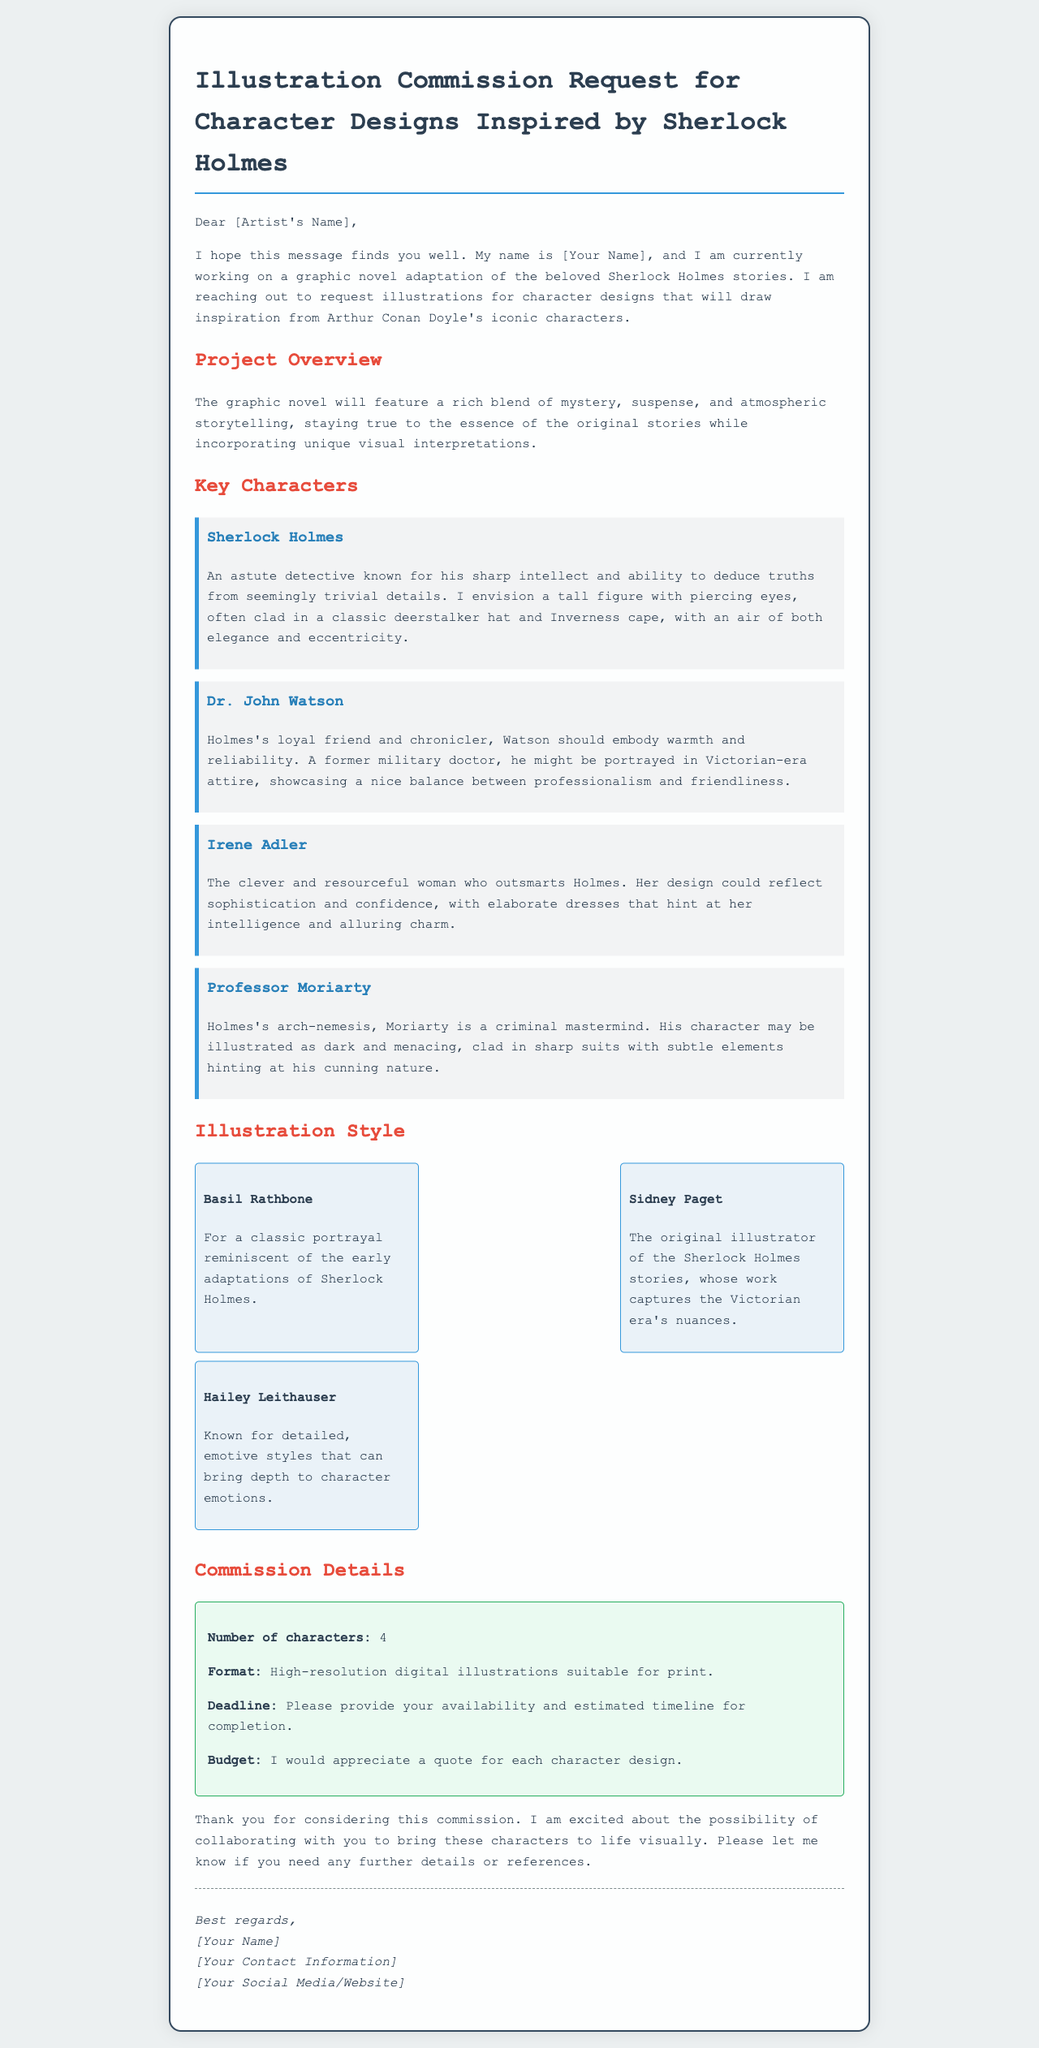What is the project about? The document states that the project is a graphic novel adaptation of the Sherlock Holmes stories.
Answer: Graphic novel adaptation of Sherlock Holmes stories How many characters are needed for the illustrations? The document specifies that four characters are required for the character designs.
Answer: 4 What character is described as the "clever and resourceful woman who outsmarts Holmes"? The document identifies Irene Adler as this character.
Answer: Irene Adler What is the format required for the illustrations? It is mentioned in the commission details that high-resolution digital illustrations suitable for print are required.
Answer: High-resolution digital illustrations suitable for print By when should the illustrations be completed? The email requests the illustrator to provide their availability and estimated timeline for completion, implying a deadline needs confirmation.
Answer: Deadline needs confirmation Which reference style is related to the original illustrator of the Sherlock Holmes stories? The document states that Sidney Paget is known for capturing the Victorian era’s nuances, linking him to the reference style.
Answer: Sidney Paget What type of details does the project aim to encompass in its storytelling? The document mentions that the novel will encompass a rich blend of mystery, suspense, and atmospheric storytelling.
Answer: Mystery, suspense, and atmospheric storytelling What is the main theme of the graphic novel adaptation? The document highlights that the adaptation aims to stay true to the essence of the original stories while incorporating unique visual interpretations.
Answer: Unique visual interpretations 